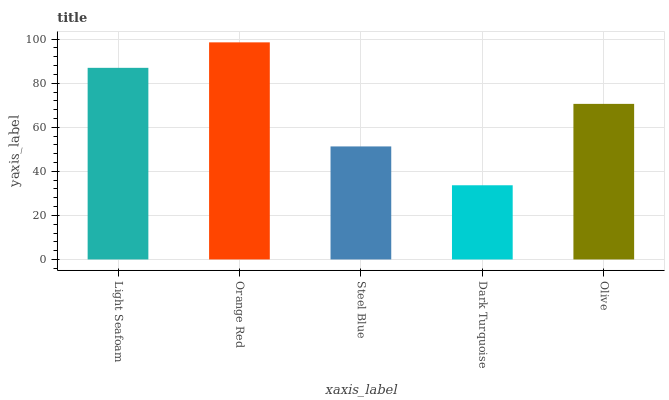Is Dark Turquoise the minimum?
Answer yes or no. Yes. Is Orange Red the maximum?
Answer yes or no. Yes. Is Steel Blue the minimum?
Answer yes or no. No. Is Steel Blue the maximum?
Answer yes or no. No. Is Orange Red greater than Steel Blue?
Answer yes or no. Yes. Is Steel Blue less than Orange Red?
Answer yes or no. Yes. Is Steel Blue greater than Orange Red?
Answer yes or no. No. Is Orange Red less than Steel Blue?
Answer yes or no. No. Is Olive the high median?
Answer yes or no. Yes. Is Olive the low median?
Answer yes or no. Yes. Is Dark Turquoise the high median?
Answer yes or no. No. Is Orange Red the low median?
Answer yes or no. No. 